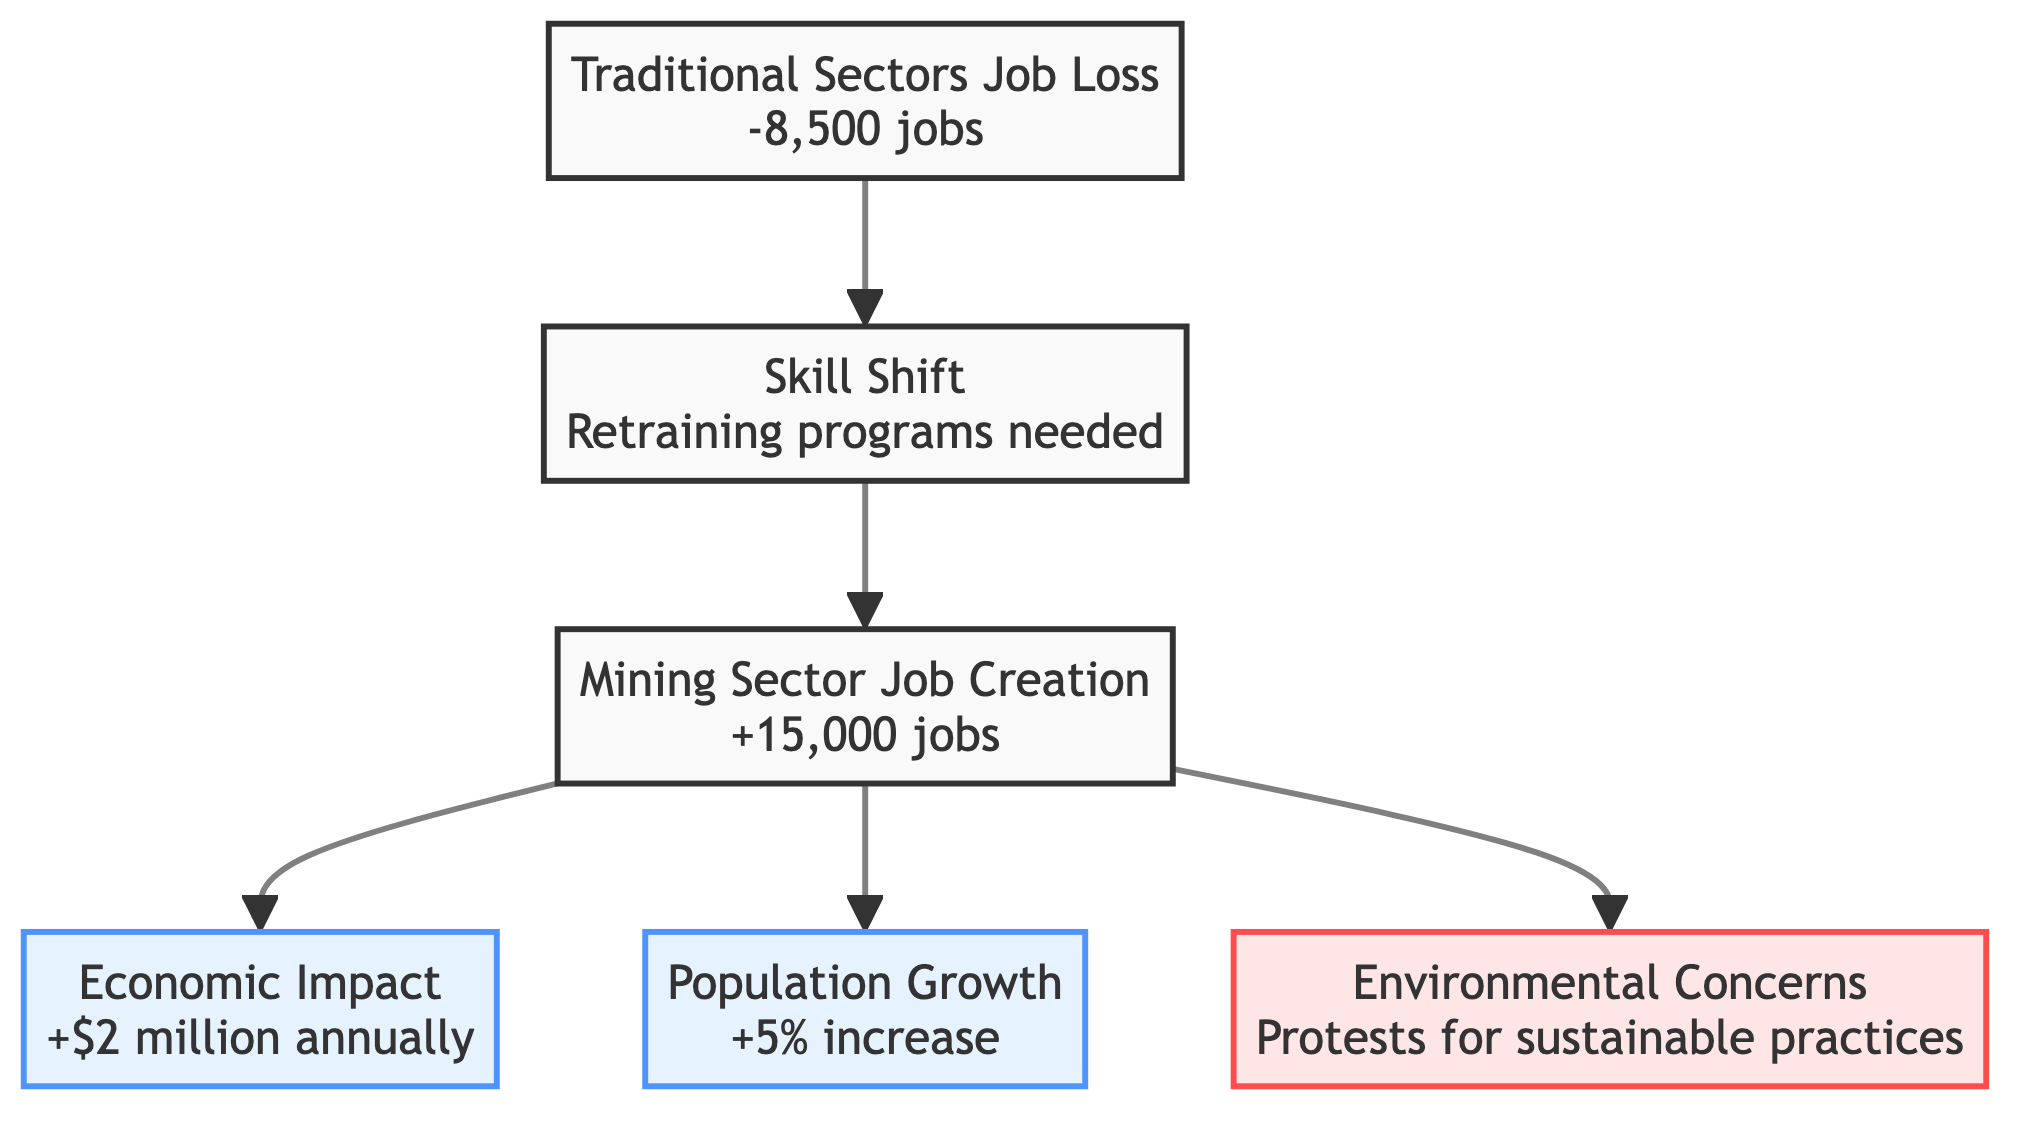What is the total job creation in the mining sector? The diagram states that the job creation in the mining sector is an increase of 15,000 jobs over the last decade.
Answer: 15,000 jobs How many jobs were lost in traditional sectors? According to the diagram, there was a decline of 8,500 jobs in traditional community sectors.
Answer: 8,500 jobs What economic impact has the mining sector had on the community? The diagram indicates that the increased community revenue from mining sector jobs is $2 million annually.
Answer: $2 million annually What is the percentage increase in population attributed to the mining sector? The diagram notes a population growth of 5% attributed to job opportunities in the mining sector.
Answer: 5% What is required for displaced workers transitioning into mining jobs? As shown in the diagram, there is a need for retraining programs for displaced workers in traditional sectors.
Answer: Retraining programs How do environmental concerns relate to mining job creation? The diagram shows that there are protests and calls for sustainable practices in response to the environmental concerns stemming from job creation in the mining sector.
Answer: Protests and calls for sustainable practices Which node directly influences the Economic Impact node? The diagram indicates that the Mining Sector Job Creation node directly influences the Economic Impact node, as there is a direct link from one to the other.
Answer: Mining Sector Job Creation How many main elements are represented in the diagram? The diagram identifies a total of six main elements: Mining Job Creation, Traditional Sector Job Loss, Economic Impact, Skill Shift, Population Growth, and Environmental Concerns.
Answer: Six elements What type of relationships are shown between the Mining Job Creation and Traditional Sector Job Loss? The diagram shows that there are opposing relationships; while there is job creation in the Mining sector, it is contrasted with job loss in Traditional sectors, indicating an economic shift.
Answer: Opposing relationships 